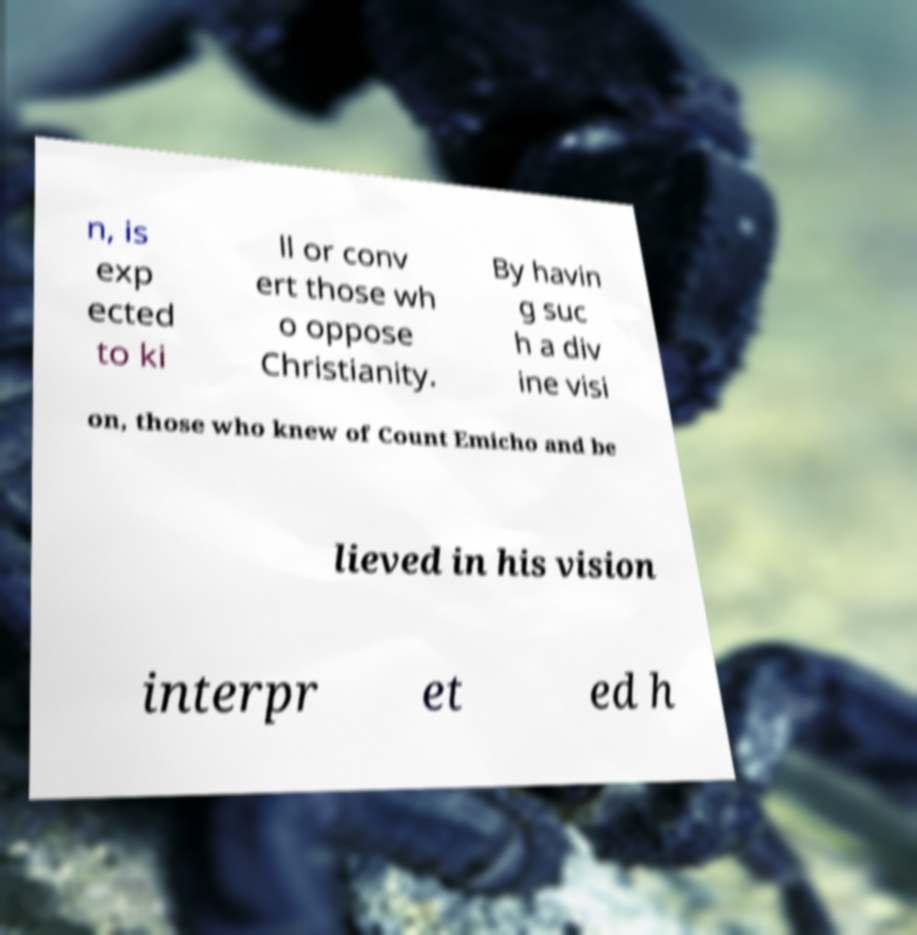There's text embedded in this image that I need extracted. Can you transcribe it verbatim? n, is exp ected to ki ll or conv ert those wh o oppose Christianity. By havin g suc h a div ine visi on, those who knew of Count Emicho and be lieved in his vision interpr et ed h 